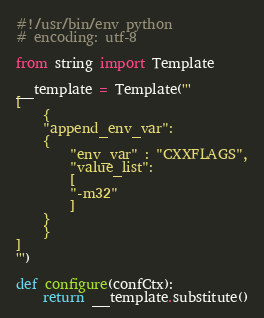<code> <loc_0><loc_0><loc_500><loc_500><_Python_>#!/usr/bin/env python
# encoding: utf-8

from string import Template

__template = Template('''
[
    {
	"append_env_var":
	{
	    "env_var" : "CXXFLAGS",
	    "value_list":
	    [
		"-m32"
	    ]
	}
    }
]
''')

def configure(confCtx):
    return __template.substitute()
</code> 